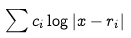Convert formula to latex. <formula><loc_0><loc_0><loc_500><loc_500>\sum c _ { i } \log | x - r _ { i } |</formula> 